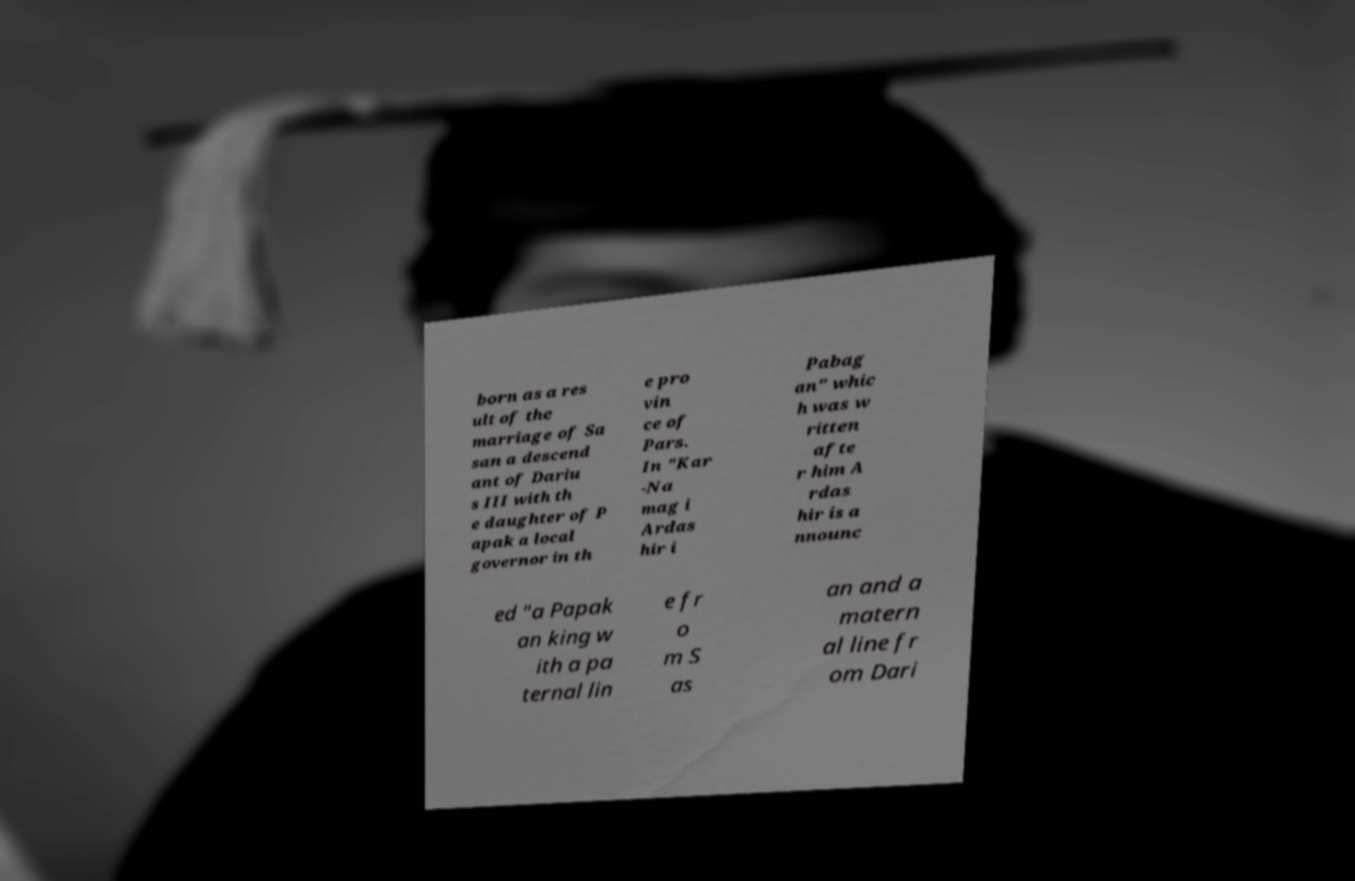Please identify and transcribe the text found in this image. born as a res ult of the marriage of Sa san a descend ant of Dariu s III with th e daughter of P apak a local governor in th e pro vin ce of Pars. In "Kar -Na mag i Ardas hir i Pabag an" whic h was w ritten afte r him A rdas hir is a nnounc ed "a Papak an king w ith a pa ternal lin e fr o m S as an and a matern al line fr om Dari 